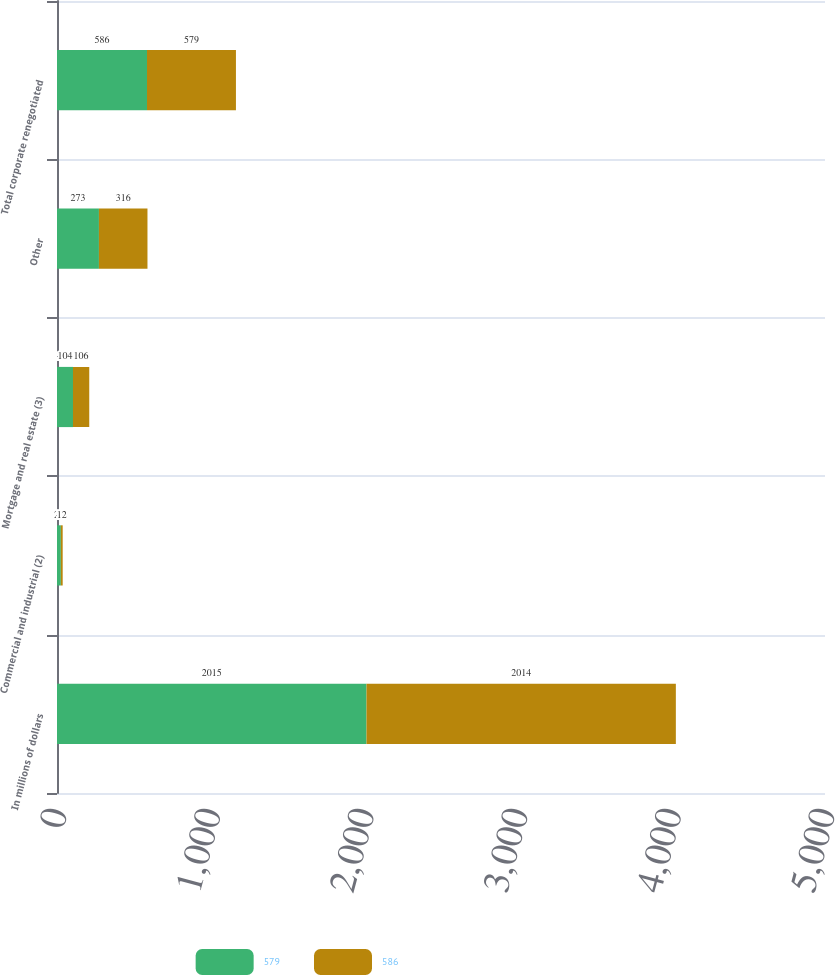Convert chart. <chart><loc_0><loc_0><loc_500><loc_500><stacked_bar_chart><ecel><fcel>In millions of dollars<fcel>Commercial and industrial (2)<fcel>Mortgage and real estate (3)<fcel>Other<fcel>Total corporate renegotiated<nl><fcel>579<fcel>2015<fcel>25<fcel>104<fcel>273<fcel>586<nl><fcel>586<fcel>2014<fcel>12<fcel>106<fcel>316<fcel>579<nl></chart> 